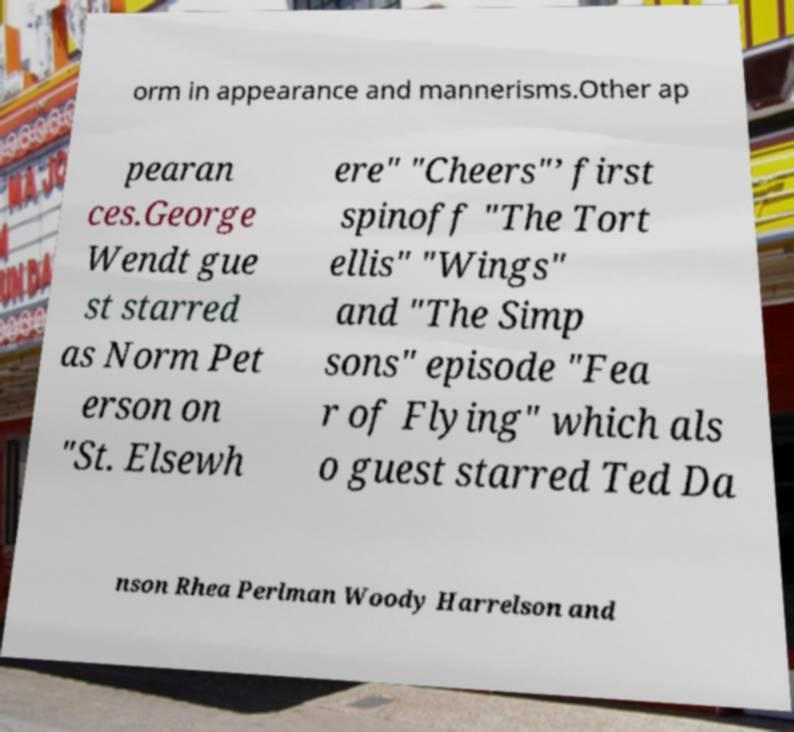Can you accurately transcribe the text from the provided image for me? orm in appearance and mannerisms.Other ap pearan ces.George Wendt gue st starred as Norm Pet erson on "St. Elsewh ere" "Cheers"’ first spinoff "The Tort ellis" "Wings" and "The Simp sons" episode "Fea r of Flying" which als o guest starred Ted Da nson Rhea Perlman Woody Harrelson and 